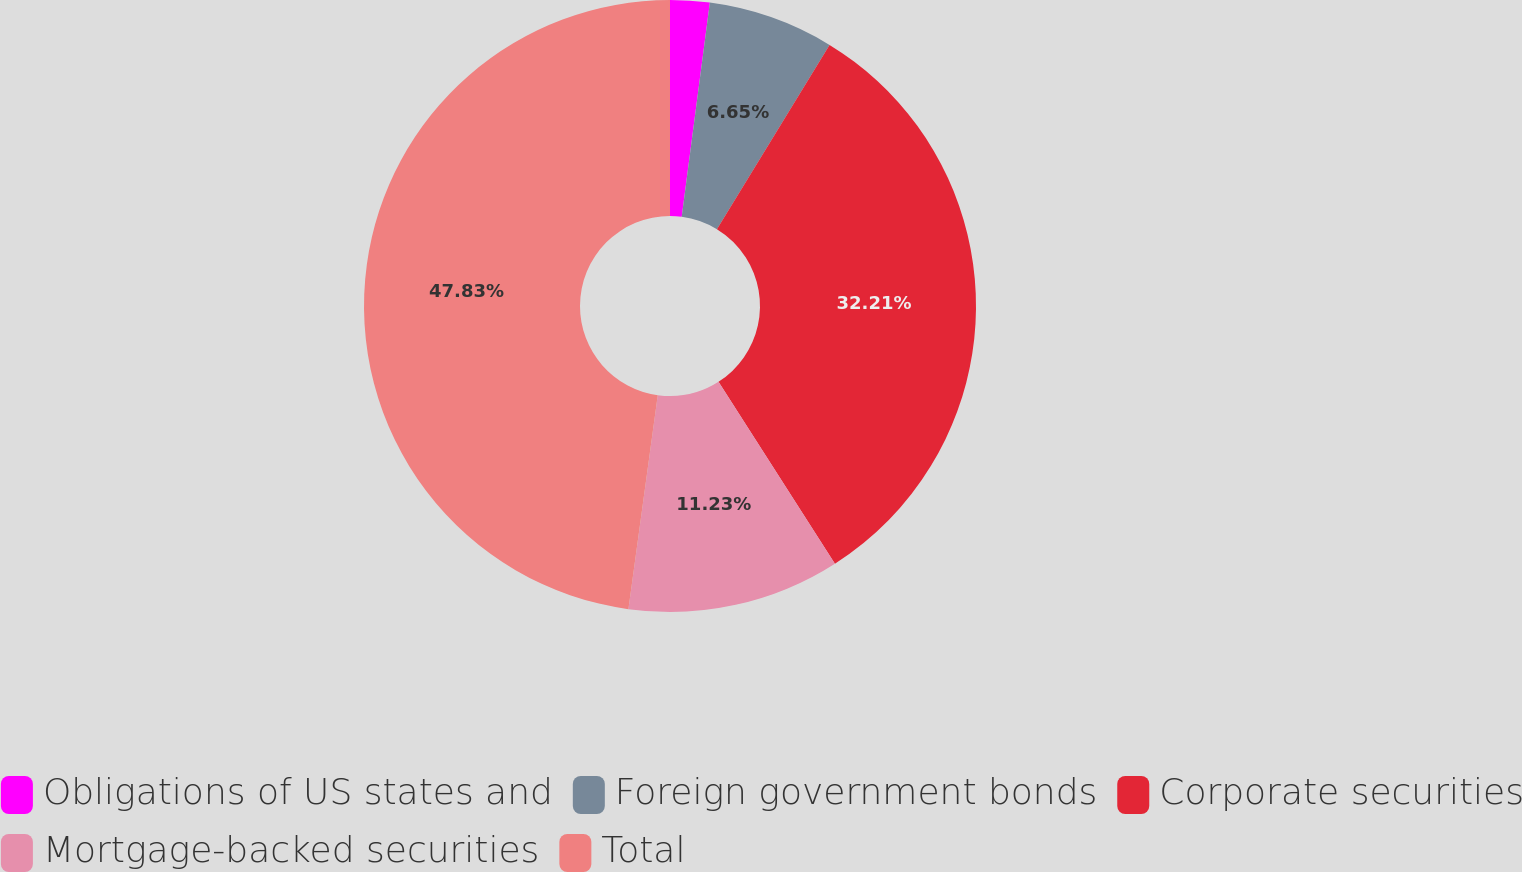Convert chart. <chart><loc_0><loc_0><loc_500><loc_500><pie_chart><fcel>Obligations of US states and<fcel>Foreign government bonds<fcel>Corporate securities<fcel>Mortgage-backed securities<fcel>Total<nl><fcel>2.08%<fcel>6.65%<fcel>32.21%<fcel>11.23%<fcel>47.83%<nl></chart> 